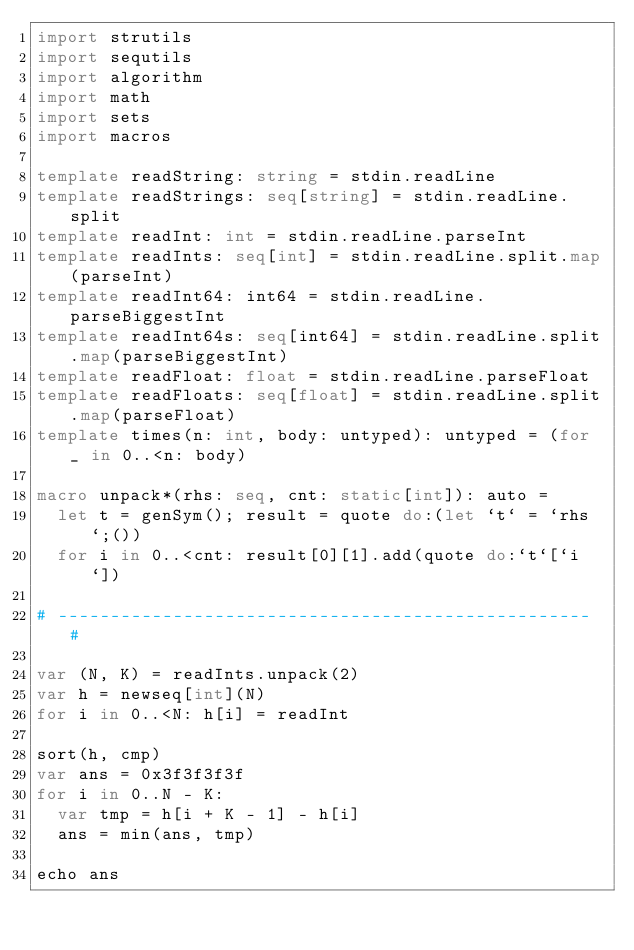Convert code to text. <code><loc_0><loc_0><loc_500><loc_500><_Nim_>import strutils
import sequtils
import algorithm
import math
import sets
import macros

template readString: string = stdin.readLine
template readStrings: seq[string] = stdin.readLine.split
template readInt: int = stdin.readLine.parseInt
template readInts: seq[int] = stdin.readLine.split.map(parseInt)
template readInt64: int64 = stdin.readLine.parseBiggestInt
template readInt64s: seq[int64] = stdin.readLine.split.map(parseBiggestInt)
template readFloat: float = stdin.readLine.parseFloat
template readFloats: seq[float] = stdin.readLine.split.map(parseFloat)
template times(n: int, body: untyped): untyped = (for _ in 0..<n: body)

macro unpack*(rhs: seq, cnt: static[int]): auto =
  let t = genSym(); result = quote do:(let `t` = `rhs`;())
  for i in 0..<cnt: result[0][1].add(quote do:`t`[`i`])

# --------------------------------------------------- #

var (N, K) = readInts.unpack(2)
var h = newseq[int](N)
for i in 0..<N: h[i] = readInt

sort(h, cmp)
var ans = 0x3f3f3f3f
for i in 0..N - K:
  var tmp = h[i + K - 1] - h[i]
  ans = min(ans, tmp)

echo ans</code> 